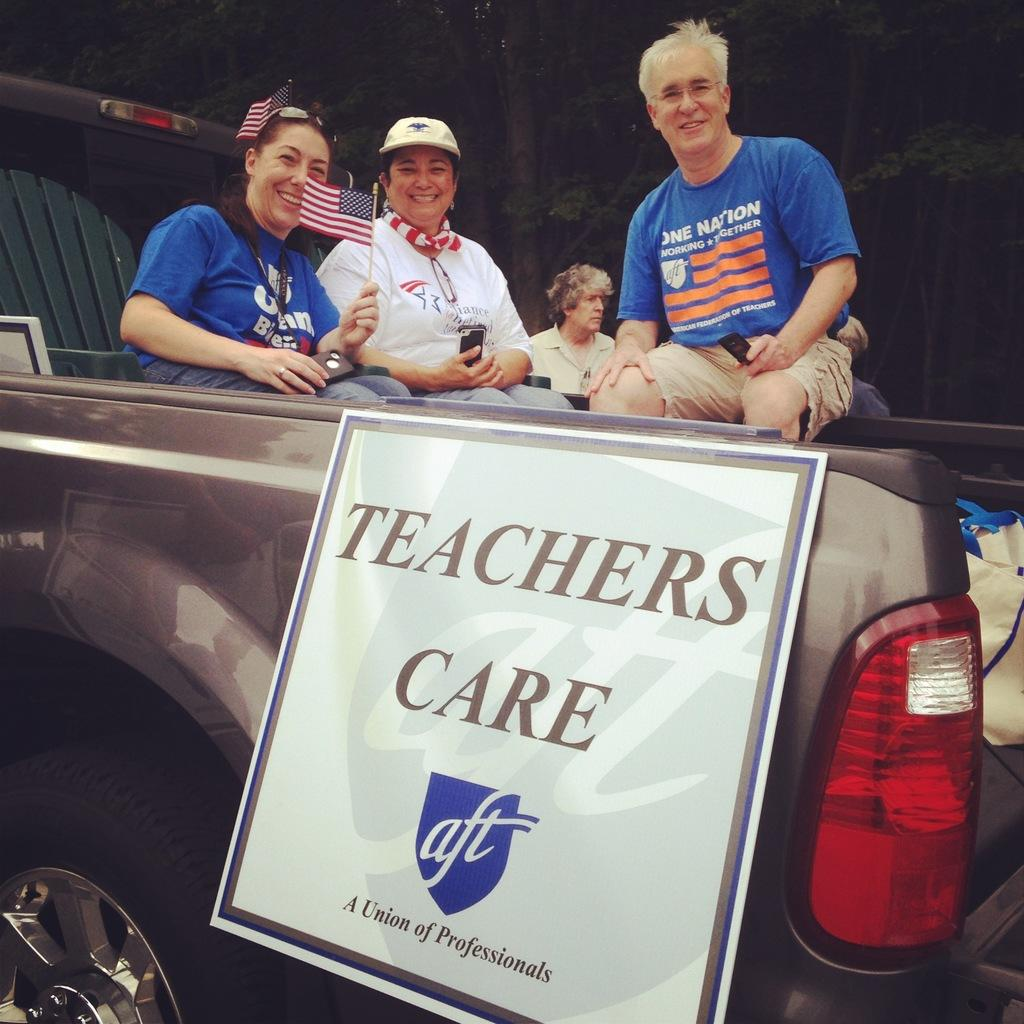What are the people in the image doing? The people in the image are sitting in a vehicle. What type of vehicle are they in? The vehicle appears to be a jeep. Is there anything attached to the vehicle? Yes, there is a board on the vehicle. What can be seen in the background of the image? There are trees in the background of the image. What route are the people taking on their desk in the image? There is no desk present in the image, and the people are sitting in a vehicle, not on a desk. 